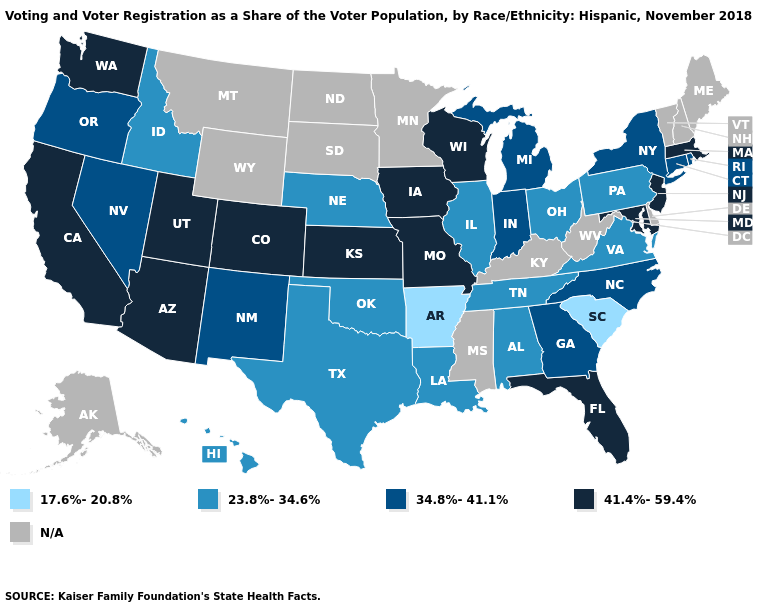Is the legend a continuous bar?
Give a very brief answer. No. What is the value of Texas?
Answer briefly. 23.8%-34.6%. What is the value of South Dakota?
Quick response, please. N/A. Name the states that have a value in the range 41.4%-59.4%?
Give a very brief answer. Arizona, California, Colorado, Florida, Iowa, Kansas, Maryland, Massachusetts, Missouri, New Jersey, Utah, Washington, Wisconsin. Which states have the lowest value in the Northeast?
Answer briefly. Pennsylvania. What is the lowest value in the South?
Answer briefly. 17.6%-20.8%. What is the lowest value in the USA?
Short answer required. 17.6%-20.8%. What is the value of Ohio?
Write a very short answer. 23.8%-34.6%. Does Nevada have the lowest value in the West?
Give a very brief answer. No. Among the states that border Kentucky , which have the highest value?
Answer briefly. Missouri. Among the states that border Florida , which have the highest value?
Answer briefly. Georgia. What is the value of New York?
Concise answer only. 34.8%-41.1%. What is the value of Montana?
Short answer required. N/A. Does the map have missing data?
Be succinct. Yes. 